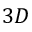Convert formula to latex. <formula><loc_0><loc_0><loc_500><loc_500>3 D</formula> 